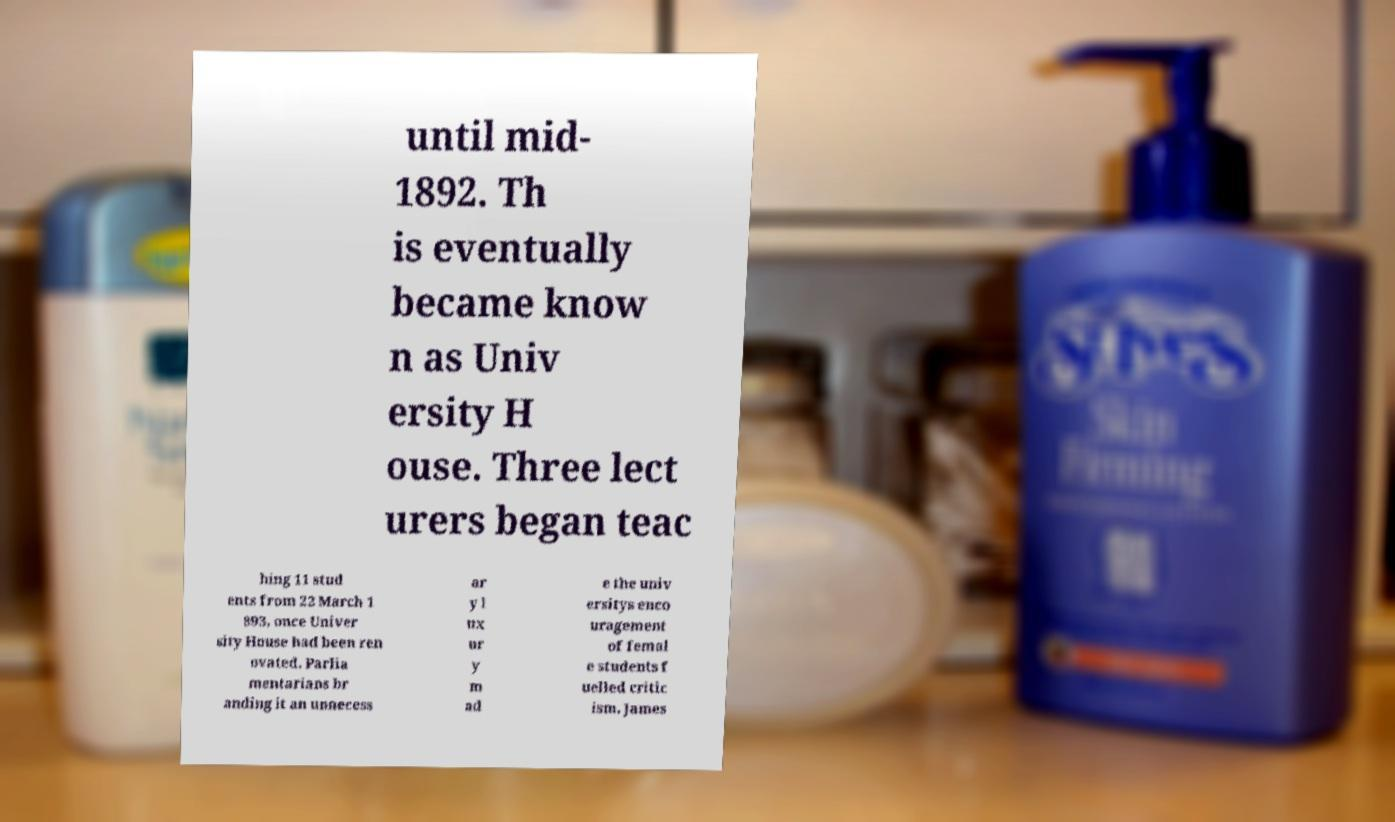There's text embedded in this image that I need extracted. Can you transcribe it verbatim? until mid- 1892. Th is eventually became know n as Univ ersity H ouse. Three lect urers began teac hing 11 stud ents from 22 March 1 893, once Univer sity House had been ren ovated. Parlia mentarians br anding it an unnecess ar y l ux ur y m ad e the univ ersitys enco uragement of femal e students f uelled critic ism. James 